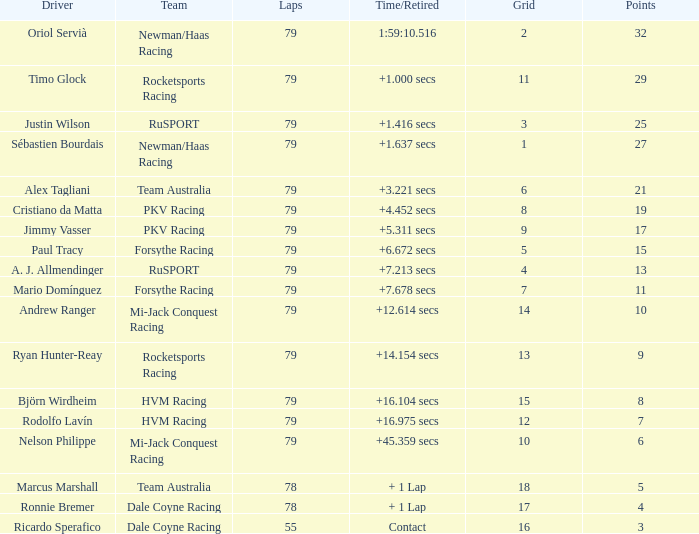What grid has 78 laps, and Ronnie Bremer as driver? 17.0. 